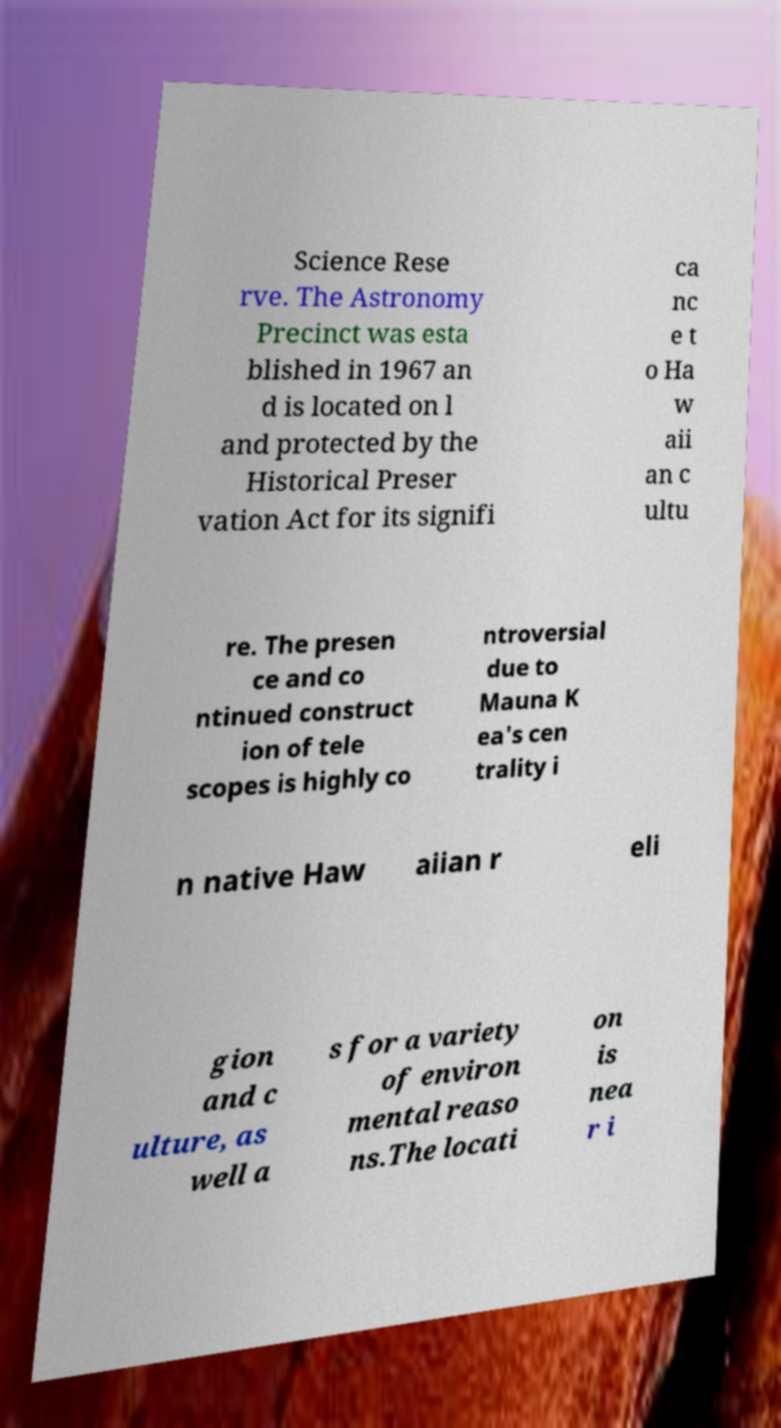I need the written content from this picture converted into text. Can you do that? Science Rese rve. The Astronomy Precinct was esta blished in 1967 an d is located on l and protected by the Historical Preser vation Act for its signifi ca nc e t o Ha w aii an c ultu re. The presen ce and co ntinued construct ion of tele scopes is highly co ntroversial due to Mauna K ea's cen trality i n native Haw aiian r eli gion and c ulture, as well a s for a variety of environ mental reaso ns.The locati on is nea r i 